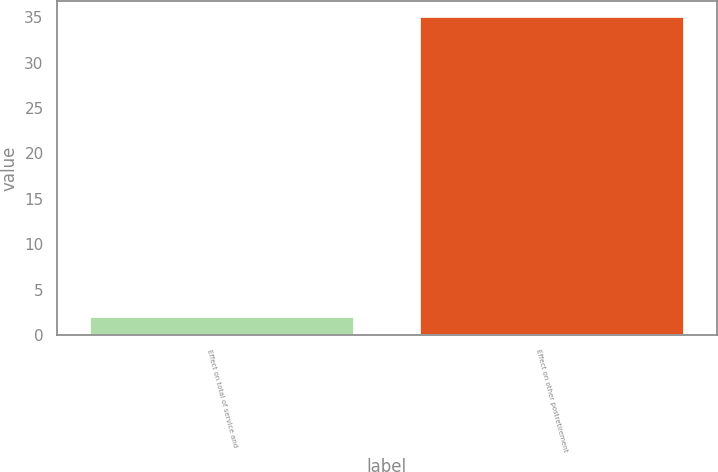Convert chart. <chart><loc_0><loc_0><loc_500><loc_500><bar_chart><fcel>Effect on total of service and<fcel>Effect on other postretirement<nl><fcel>2<fcel>35<nl></chart> 